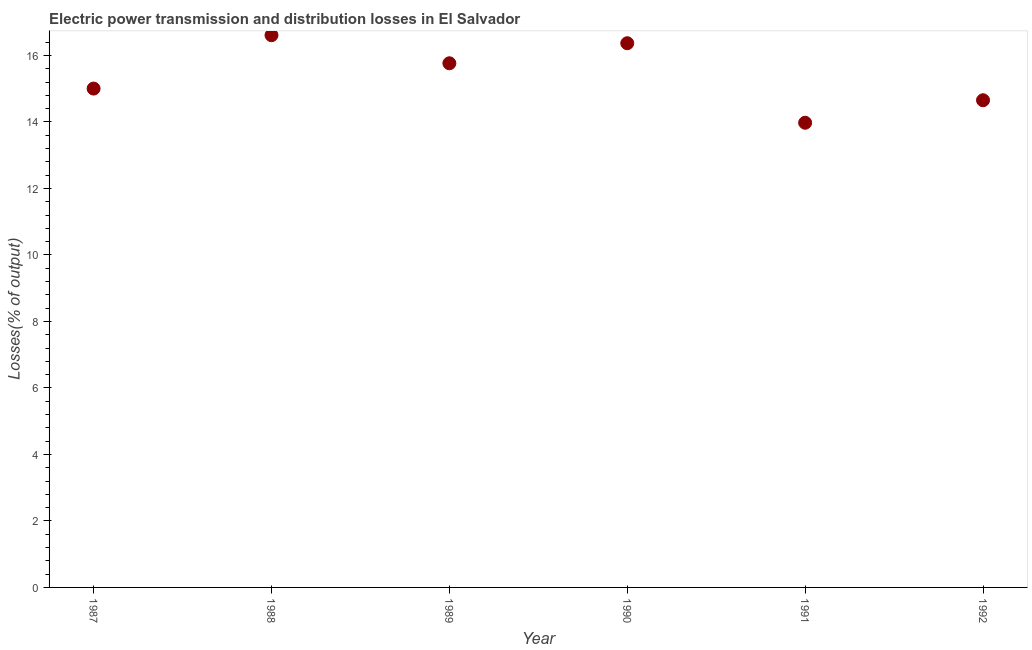What is the electric power transmission and distribution losses in 1992?
Your answer should be compact. 14.65. Across all years, what is the maximum electric power transmission and distribution losses?
Provide a succinct answer. 16.61. Across all years, what is the minimum electric power transmission and distribution losses?
Provide a succinct answer. 13.97. What is the sum of the electric power transmission and distribution losses?
Offer a terse response. 92.37. What is the difference between the electric power transmission and distribution losses in 1988 and 1990?
Your answer should be very brief. 0.24. What is the average electric power transmission and distribution losses per year?
Provide a succinct answer. 15.39. What is the median electric power transmission and distribution losses?
Make the answer very short. 15.38. In how many years, is the electric power transmission and distribution losses greater than 10 %?
Provide a short and direct response. 6. Do a majority of the years between 1990 and 1987 (inclusive) have electric power transmission and distribution losses greater than 3.2 %?
Make the answer very short. Yes. What is the ratio of the electric power transmission and distribution losses in 1990 to that in 1991?
Your answer should be compact. 1.17. Is the difference between the electric power transmission and distribution losses in 1987 and 1990 greater than the difference between any two years?
Ensure brevity in your answer.  No. What is the difference between the highest and the second highest electric power transmission and distribution losses?
Your answer should be compact. 0.24. Is the sum of the electric power transmission and distribution losses in 1991 and 1992 greater than the maximum electric power transmission and distribution losses across all years?
Make the answer very short. Yes. What is the difference between the highest and the lowest electric power transmission and distribution losses?
Make the answer very short. 2.63. Does the electric power transmission and distribution losses monotonically increase over the years?
Provide a succinct answer. No. Are the values on the major ticks of Y-axis written in scientific E-notation?
Keep it short and to the point. No. What is the title of the graph?
Provide a short and direct response. Electric power transmission and distribution losses in El Salvador. What is the label or title of the X-axis?
Give a very brief answer. Year. What is the label or title of the Y-axis?
Provide a short and direct response. Losses(% of output). What is the Losses(% of output) in 1987?
Offer a very short reply. 15. What is the Losses(% of output) in 1988?
Your response must be concise. 16.61. What is the Losses(% of output) in 1989?
Ensure brevity in your answer.  15.76. What is the Losses(% of output) in 1990?
Provide a short and direct response. 16.37. What is the Losses(% of output) in 1991?
Offer a very short reply. 13.97. What is the Losses(% of output) in 1992?
Keep it short and to the point. 14.65. What is the difference between the Losses(% of output) in 1987 and 1988?
Keep it short and to the point. -1.61. What is the difference between the Losses(% of output) in 1987 and 1989?
Your answer should be compact. -0.76. What is the difference between the Losses(% of output) in 1987 and 1990?
Your answer should be compact. -1.36. What is the difference between the Losses(% of output) in 1987 and 1991?
Your response must be concise. 1.03. What is the difference between the Losses(% of output) in 1987 and 1992?
Ensure brevity in your answer.  0.35. What is the difference between the Losses(% of output) in 1988 and 1989?
Provide a succinct answer. 0.84. What is the difference between the Losses(% of output) in 1988 and 1990?
Your answer should be compact. 0.24. What is the difference between the Losses(% of output) in 1988 and 1991?
Offer a terse response. 2.63. What is the difference between the Losses(% of output) in 1988 and 1992?
Provide a succinct answer. 1.96. What is the difference between the Losses(% of output) in 1989 and 1990?
Make the answer very short. -0.6. What is the difference between the Losses(% of output) in 1989 and 1991?
Your answer should be compact. 1.79. What is the difference between the Losses(% of output) in 1989 and 1992?
Provide a succinct answer. 1.11. What is the difference between the Losses(% of output) in 1990 and 1991?
Keep it short and to the point. 2.39. What is the difference between the Losses(% of output) in 1990 and 1992?
Make the answer very short. 1.71. What is the difference between the Losses(% of output) in 1991 and 1992?
Your answer should be compact. -0.68. What is the ratio of the Losses(% of output) in 1987 to that in 1988?
Provide a short and direct response. 0.9. What is the ratio of the Losses(% of output) in 1987 to that in 1990?
Provide a short and direct response. 0.92. What is the ratio of the Losses(% of output) in 1987 to that in 1991?
Keep it short and to the point. 1.07. What is the ratio of the Losses(% of output) in 1987 to that in 1992?
Ensure brevity in your answer.  1.02. What is the ratio of the Losses(% of output) in 1988 to that in 1989?
Give a very brief answer. 1.05. What is the ratio of the Losses(% of output) in 1988 to that in 1991?
Give a very brief answer. 1.19. What is the ratio of the Losses(% of output) in 1988 to that in 1992?
Offer a very short reply. 1.13. What is the ratio of the Losses(% of output) in 1989 to that in 1991?
Offer a very short reply. 1.13. What is the ratio of the Losses(% of output) in 1989 to that in 1992?
Offer a terse response. 1.08. What is the ratio of the Losses(% of output) in 1990 to that in 1991?
Your answer should be compact. 1.17. What is the ratio of the Losses(% of output) in 1990 to that in 1992?
Provide a short and direct response. 1.12. What is the ratio of the Losses(% of output) in 1991 to that in 1992?
Make the answer very short. 0.95. 